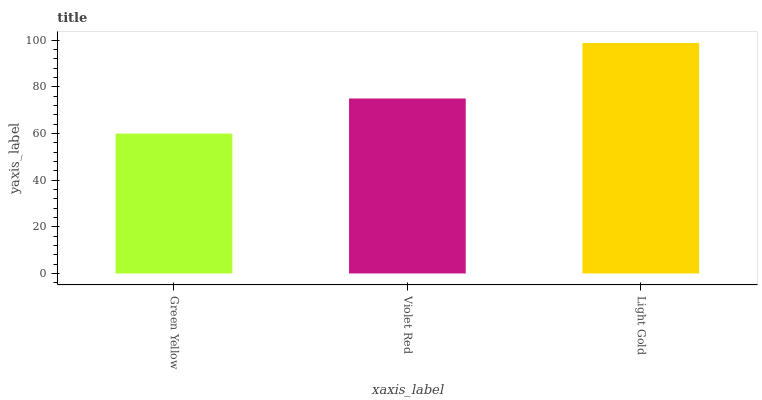Is Violet Red the minimum?
Answer yes or no. No. Is Violet Red the maximum?
Answer yes or no. No. Is Violet Red greater than Green Yellow?
Answer yes or no. Yes. Is Green Yellow less than Violet Red?
Answer yes or no. Yes. Is Green Yellow greater than Violet Red?
Answer yes or no. No. Is Violet Red less than Green Yellow?
Answer yes or no. No. Is Violet Red the high median?
Answer yes or no. Yes. Is Violet Red the low median?
Answer yes or no. Yes. Is Green Yellow the high median?
Answer yes or no. No. Is Light Gold the low median?
Answer yes or no. No. 